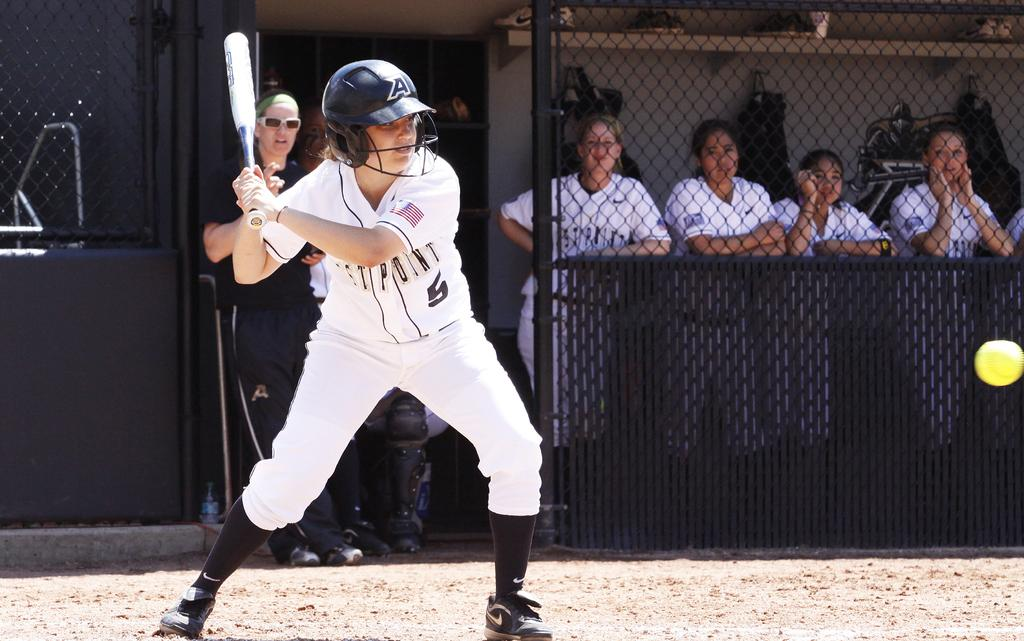<image>
Describe the image concisely. A baseball player representing West Point wears jersey number 5. 